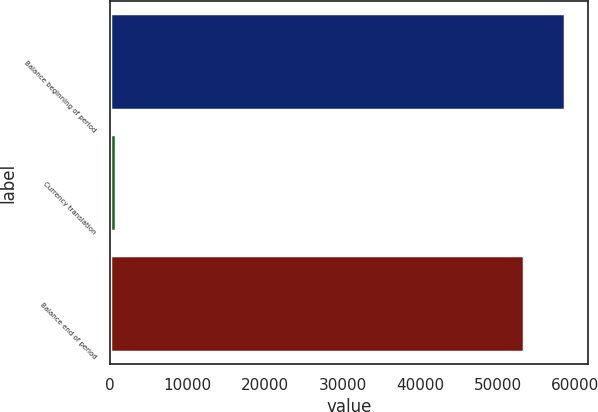Convert chart to OTSL. <chart><loc_0><loc_0><loc_500><loc_500><bar_chart><fcel>Balance beginning of period<fcel>Currency translation<fcel>Balance end of period<nl><fcel>58730.1<fcel>791<fcel>53391<nl></chart> 